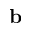<formula> <loc_0><loc_0><loc_500><loc_500>b</formula> 